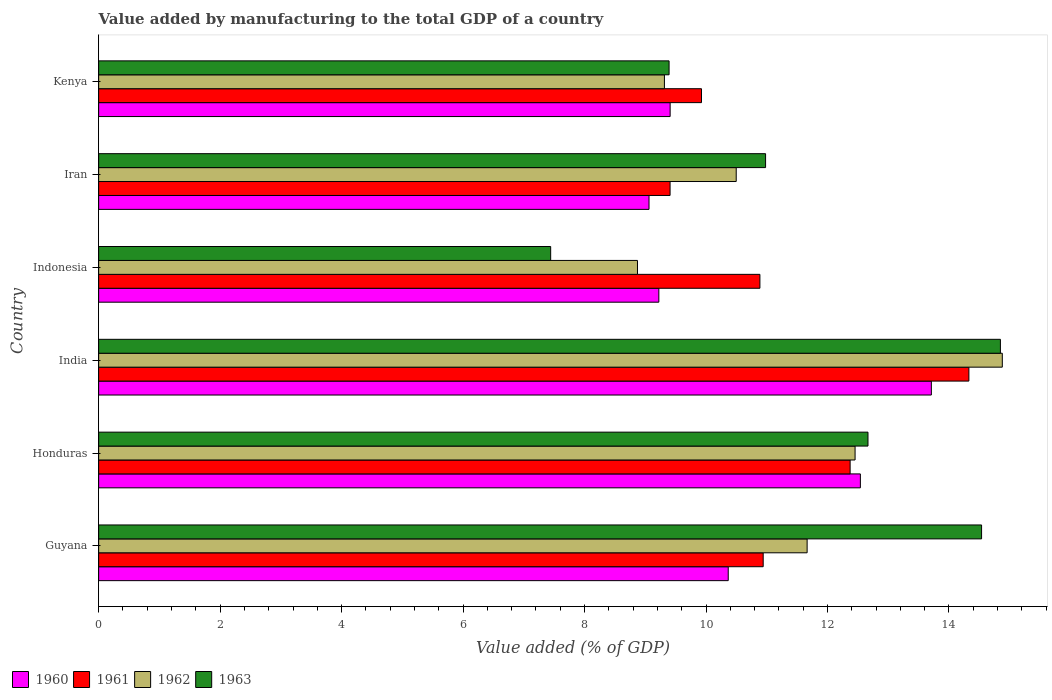What is the label of the 2nd group of bars from the top?
Give a very brief answer. Iran. In how many cases, is the number of bars for a given country not equal to the number of legend labels?
Ensure brevity in your answer.  0. What is the value added by manufacturing to the total GDP in 1960 in India?
Your answer should be very brief. 13.71. Across all countries, what is the maximum value added by manufacturing to the total GDP in 1960?
Provide a short and direct response. 13.71. Across all countries, what is the minimum value added by manufacturing to the total GDP in 1963?
Provide a short and direct response. 7.44. In which country was the value added by manufacturing to the total GDP in 1962 maximum?
Offer a very short reply. India. In which country was the value added by manufacturing to the total GDP in 1961 minimum?
Your answer should be compact. Iran. What is the total value added by manufacturing to the total GDP in 1961 in the graph?
Provide a succinct answer. 67.86. What is the difference between the value added by manufacturing to the total GDP in 1963 in Iran and that in Kenya?
Your response must be concise. 1.59. What is the difference between the value added by manufacturing to the total GDP in 1962 in Kenya and the value added by manufacturing to the total GDP in 1960 in Iran?
Ensure brevity in your answer.  0.25. What is the average value added by manufacturing to the total GDP in 1963 per country?
Give a very brief answer. 11.64. What is the difference between the value added by manufacturing to the total GDP in 1963 and value added by manufacturing to the total GDP in 1962 in Guyana?
Offer a terse response. 2.87. In how many countries, is the value added by manufacturing to the total GDP in 1962 greater than 12.8 %?
Provide a short and direct response. 1. What is the ratio of the value added by manufacturing to the total GDP in 1963 in Guyana to that in India?
Make the answer very short. 0.98. Is the value added by manufacturing to the total GDP in 1963 in Guyana less than that in India?
Your answer should be compact. Yes. What is the difference between the highest and the second highest value added by manufacturing to the total GDP in 1961?
Make the answer very short. 1.96. What is the difference between the highest and the lowest value added by manufacturing to the total GDP in 1960?
Your response must be concise. 4.65. Is the sum of the value added by manufacturing to the total GDP in 1961 in Indonesia and Iran greater than the maximum value added by manufacturing to the total GDP in 1962 across all countries?
Your response must be concise. Yes. Is it the case that in every country, the sum of the value added by manufacturing to the total GDP in 1962 and value added by manufacturing to the total GDP in 1961 is greater than the sum of value added by manufacturing to the total GDP in 1960 and value added by manufacturing to the total GDP in 1963?
Offer a very short reply. No. What does the 1st bar from the top in Honduras represents?
Offer a terse response. 1963. Is it the case that in every country, the sum of the value added by manufacturing to the total GDP in 1963 and value added by manufacturing to the total GDP in 1960 is greater than the value added by manufacturing to the total GDP in 1962?
Ensure brevity in your answer.  Yes. How many bars are there?
Offer a very short reply. 24. How many countries are there in the graph?
Give a very brief answer. 6. What is the difference between two consecutive major ticks on the X-axis?
Provide a succinct answer. 2. How many legend labels are there?
Your answer should be very brief. 4. How are the legend labels stacked?
Your answer should be compact. Horizontal. What is the title of the graph?
Offer a terse response. Value added by manufacturing to the total GDP of a country. Does "2008" appear as one of the legend labels in the graph?
Your answer should be compact. No. What is the label or title of the X-axis?
Give a very brief answer. Value added (% of GDP). What is the Value added (% of GDP) of 1960 in Guyana?
Your answer should be compact. 10.37. What is the Value added (% of GDP) of 1961 in Guyana?
Provide a succinct answer. 10.94. What is the Value added (% of GDP) of 1962 in Guyana?
Keep it short and to the point. 11.66. What is the Value added (% of GDP) in 1963 in Guyana?
Make the answer very short. 14.54. What is the Value added (% of GDP) in 1960 in Honduras?
Your answer should be compact. 12.54. What is the Value added (% of GDP) in 1961 in Honduras?
Your answer should be compact. 12.37. What is the Value added (% of GDP) in 1962 in Honduras?
Provide a short and direct response. 12.45. What is the Value added (% of GDP) in 1963 in Honduras?
Your answer should be compact. 12.67. What is the Value added (% of GDP) of 1960 in India?
Provide a short and direct response. 13.71. What is the Value added (% of GDP) in 1961 in India?
Offer a very short reply. 14.33. What is the Value added (% of GDP) in 1962 in India?
Provide a succinct answer. 14.88. What is the Value added (% of GDP) of 1963 in India?
Provide a short and direct response. 14.85. What is the Value added (% of GDP) of 1960 in Indonesia?
Offer a very short reply. 9.22. What is the Value added (% of GDP) of 1961 in Indonesia?
Keep it short and to the point. 10.89. What is the Value added (% of GDP) in 1962 in Indonesia?
Your answer should be very brief. 8.87. What is the Value added (% of GDP) of 1963 in Indonesia?
Keep it short and to the point. 7.44. What is the Value added (% of GDP) in 1960 in Iran?
Your answer should be very brief. 9.06. What is the Value added (% of GDP) of 1961 in Iran?
Your answer should be very brief. 9.41. What is the Value added (% of GDP) of 1962 in Iran?
Make the answer very short. 10.5. What is the Value added (% of GDP) of 1963 in Iran?
Offer a terse response. 10.98. What is the Value added (% of GDP) of 1960 in Kenya?
Make the answer very short. 9.41. What is the Value added (% of GDP) in 1961 in Kenya?
Offer a terse response. 9.93. What is the Value added (% of GDP) in 1962 in Kenya?
Provide a succinct answer. 9.32. What is the Value added (% of GDP) in 1963 in Kenya?
Provide a short and direct response. 9.39. Across all countries, what is the maximum Value added (% of GDP) of 1960?
Ensure brevity in your answer.  13.71. Across all countries, what is the maximum Value added (% of GDP) in 1961?
Your answer should be very brief. 14.33. Across all countries, what is the maximum Value added (% of GDP) of 1962?
Provide a short and direct response. 14.88. Across all countries, what is the maximum Value added (% of GDP) of 1963?
Provide a succinct answer. 14.85. Across all countries, what is the minimum Value added (% of GDP) in 1960?
Give a very brief answer. 9.06. Across all countries, what is the minimum Value added (% of GDP) in 1961?
Your answer should be very brief. 9.41. Across all countries, what is the minimum Value added (% of GDP) in 1962?
Make the answer very short. 8.87. Across all countries, what is the minimum Value added (% of GDP) in 1963?
Keep it short and to the point. 7.44. What is the total Value added (% of GDP) of 1960 in the graph?
Offer a very short reply. 64.31. What is the total Value added (% of GDP) in 1961 in the graph?
Ensure brevity in your answer.  67.86. What is the total Value added (% of GDP) in 1962 in the graph?
Provide a short and direct response. 67.68. What is the total Value added (% of GDP) of 1963 in the graph?
Your answer should be very brief. 69.86. What is the difference between the Value added (% of GDP) of 1960 in Guyana and that in Honduras?
Provide a short and direct response. -2.18. What is the difference between the Value added (% of GDP) in 1961 in Guyana and that in Honduras?
Your answer should be very brief. -1.43. What is the difference between the Value added (% of GDP) in 1962 in Guyana and that in Honduras?
Offer a terse response. -0.79. What is the difference between the Value added (% of GDP) of 1963 in Guyana and that in Honduras?
Provide a succinct answer. 1.87. What is the difference between the Value added (% of GDP) in 1960 in Guyana and that in India?
Keep it short and to the point. -3.34. What is the difference between the Value added (% of GDP) in 1961 in Guyana and that in India?
Offer a very short reply. -3.39. What is the difference between the Value added (% of GDP) in 1962 in Guyana and that in India?
Provide a short and direct response. -3.21. What is the difference between the Value added (% of GDP) in 1963 in Guyana and that in India?
Provide a short and direct response. -0.31. What is the difference between the Value added (% of GDP) in 1960 in Guyana and that in Indonesia?
Give a very brief answer. 1.14. What is the difference between the Value added (% of GDP) in 1961 in Guyana and that in Indonesia?
Offer a very short reply. 0.05. What is the difference between the Value added (% of GDP) in 1962 in Guyana and that in Indonesia?
Make the answer very short. 2.79. What is the difference between the Value added (% of GDP) of 1963 in Guyana and that in Indonesia?
Provide a short and direct response. 7.09. What is the difference between the Value added (% of GDP) of 1960 in Guyana and that in Iran?
Offer a terse response. 1.3. What is the difference between the Value added (% of GDP) of 1961 in Guyana and that in Iran?
Your answer should be compact. 1.53. What is the difference between the Value added (% of GDP) in 1962 in Guyana and that in Iran?
Make the answer very short. 1.17. What is the difference between the Value added (% of GDP) of 1963 in Guyana and that in Iran?
Make the answer very short. 3.56. What is the difference between the Value added (% of GDP) of 1960 in Guyana and that in Kenya?
Your answer should be compact. 0.96. What is the difference between the Value added (% of GDP) of 1961 in Guyana and that in Kenya?
Give a very brief answer. 1.02. What is the difference between the Value added (% of GDP) in 1962 in Guyana and that in Kenya?
Make the answer very short. 2.35. What is the difference between the Value added (% of GDP) of 1963 in Guyana and that in Kenya?
Make the answer very short. 5.14. What is the difference between the Value added (% of GDP) of 1960 in Honduras and that in India?
Make the answer very short. -1.17. What is the difference between the Value added (% of GDP) in 1961 in Honduras and that in India?
Your response must be concise. -1.96. What is the difference between the Value added (% of GDP) of 1962 in Honduras and that in India?
Give a very brief answer. -2.42. What is the difference between the Value added (% of GDP) of 1963 in Honduras and that in India?
Provide a short and direct response. -2.18. What is the difference between the Value added (% of GDP) of 1960 in Honduras and that in Indonesia?
Offer a very short reply. 3.32. What is the difference between the Value added (% of GDP) of 1961 in Honduras and that in Indonesia?
Make the answer very short. 1.49. What is the difference between the Value added (% of GDP) of 1962 in Honduras and that in Indonesia?
Your response must be concise. 3.58. What is the difference between the Value added (% of GDP) in 1963 in Honduras and that in Indonesia?
Make the answer very short. 5.22. What is the difference between the Value added (% of GDP) of 1960 in Honduras and that in Iran?
Make the answer very short. 3.48. What is the difference between the Value added (% of GDP) in 1961 in Honduras and that in Iran?
Keep it short and to the point. 2.96. What is the difference between the Value added (% of GDP) in 1962 in Honduras and that in Iran?
Provide a short and direct response. 1.96. What is the difference between the Value added (% of GDP) in 1963 in Honduras and that in Iran?
Give a very brief answer. 1.69. What is the difference between the Value added (% of GDP) of 1960 in Honduras and that in Kenya?
Give a very brief answer. 3.13. What is the difference between the Value added (% of GDP) of 1961 in Honduras and that in Kenya?
Make the answer very short. 2.45. What is the difference between the Value added (% of GDP) in 1962 in Honduras and that in Kenya?
Offer a terse response. 3.14. What is the difference between the Value added (% of GDP) in 1963 in Honduras and that in Kenya?
Provide a short and direct response. 3.27. What is the difference between the Value added (% of GDP) in 1960 in India and that in Indonesia?
Offer a very short reply. 4.49. What is the difference between the Value added (% of GDP) of 1961 in India and that in Indonesia?
Provide a short and direct response. 3.44. What is the difference between the Value added (% of GDP) of 1962 in India and that in Indonesia?
Provide a short and direct response. 6.01. What is the difference between the Value added (% of GDP) in 1963 in India and that in Indonesia?
Give a very brief answer. 7.4. What is the difference between the Value added (% of GDP) of 1960 in India and that in Iran?
Provide a short and direct response. 4.65. What is the difference between the Value added (% of GDP) in 1961 in India and that in Iran?
Keep it short and to the point. 4.92. What is the difference between the Value added (% of GDP) in 1962 in India and that in Iran?
Make the answer very short. 4.38. What is the difference between the Value added (% of GDP) in 1963 in India and that in Iran?
Offer a very short reply. 3.87. What is the difference between the Value added (% of GDP) in 1960 in India and that in Kenya?
Keep it short and to the point. 4.3. What is the difference between the Value added (% of GDP) in 1961 in India and that in Kenya?
Your answer should be compact. 4.4. What is the difference between the Value added (% of GDP) of 1962 in India and that in Kenya?
Provide a succinct answer. 5.56. What is the difference between the Value added (% of GDP) in 1963 in India and that in Kenya?
Your answer should be very brief. 5.45. What is the difference between the Value added (% of GDP) in 1960 in Indonesia and that in Iran?
Your answer should be compact. 0.16. What is the difference between the Value added (% of GDP) of 1961 in Indonesia and that in Iran?
Your response must be concise. 1.48. What is the difference between the Value added (% of GDP) of 1962 in Indonesia and that in Iran?
Provide a succinct answer. -1.63. What is the difference between the Value added (% of GDP) in 1963 in Indonesia and that in Iran?
Provide a short and direct response. -3.54. What is the difference between the Value added (% of GDP) in 1960 in Indonesia and that in Kenya?
Make the answer very short. -0.19. What is the difference between the Value added (% of GDP) of 1961 in Indonesia and that in Kenya?
Offer a very short reply. 0.96. What is the difference between the Value added (% of GDP) of 1962 in Indonesia and that in Kenya?
Keep it short and to the point. -0.44. What is the difference between the Value added (% of GDP) of 1963 in Indonesia and that in Kenya?
Offer a terse response. -1.95. What is the difference between the Value added (% of GDP) of 1960 in Iran and that in Kenya?
Provide a short and direct response. -0.35. What is the difference between the Value added (% of GDP) of 1961 in Iran and that in Kenya?
Ensure brevity in your answer.  -0.52. What is the difference between the Value added (% of GDP) in 1962 in Iran and that in Kenya?
Offer a very short reply. 1.18. What is the difference between the Value added (% of GDP) in 1963 in Iran and that in Kenya?
Provide a succinct answer. 1.59. What is the difference between the Value added (% of GDP) of 1960 in Guyana and the Value added (% of GDP) of 1961 in Honduras?
Offer a very short reply. -2.01. What is the difference between the Value added (% of GDP) of 1960 in Guyana and the Value added (% of GDP) of 1962 in Honduras?
Your answer should be compact. -2.09. What is the difference between the Value added (% of GDP) in 1960 in Guyana and the Value added (% of GDP) in 1963 in Honduras?
Provide a short and direct response. -2.3. What is the difference between the Value added (% of GDP) in 1961 in Guyana and the Value added (% of GDP) in 1962 in Honduras?
Make the answer very short. -1.51. What is the difference between the Value added (% of GDP) of 1961 in Guyana and the Value added (% of GDP) of 1963 in Honduras?
Give a very brief answer. -1.73. What is the difference between the Value added (% of GDP) of 1962 in Guyana and the Value added (% of GDP) of 1963 in Honduras?
Give a very brief answer. -1. What is the difference between the Value added (% of GDP) of 1960 in Guyana and the Value added (% of GDP) of 1961 in India?
Ensure brevity in your answer.  -3.96. What is the difference between the Value added (% of GDP) of 1960 in Guyana and the Value added (% of GDP) of 1962 in India?
Offer a very short reply. -4.51. What is the difference between the Value added (% of GDP) of 1960 in Guyana and the Value added (% of GDP) of 1963 in India?
Ensure brevity in your answer.  -4.48. What is the difference between the Value added (% of GDP) of 1961 in Guyana and the Value added (% of GDP) of 1962 in India?
Provide a short and direct response. -3.94. What is the difference between the Value added (% of GDP) in 1961 in Guyana and the Value added (% of GDP) in 1963 in India?
Offer a very short reply. -3.91. What is the difference between the Value added (% of GDP) in 1962 in Guyana and the Value added (% of GDP) in 1963 in India?
Give a very brief answer. -3.18. What is the difference between the Value added (% of GDP) in 1960 in Guyana and the Value added (% of GDP) in 1961 in Indonesia?
Offer a terse response. -0.52. What is the difference between the Value added (% of GDP) in 1960 in Guyana and the Value added (% of GDP) in 1962 in Indonesia?
Provide a short and direct response. 1.49. What is the difference between the Value added (% of GDP) of 1960 in Guyana and the Value added (% of GDP) of 1963 in Indonesia?
Keep it short and to the point. 2.92. What is the difference between the Value added (% of GDP) of 1961 in Guyana and the Value added (% of GDP) of 1962 in Indonesia?
Keep it short and to the point. 2.07. What is the difference between the Value added (% of GDP) of 1961 in Guyana and the Value added (% of GDP) of 1963 in Indonesia?
Offer a very short reply. 3.5. What is the difference between the Value added (% of GDP) of 1962 in Guyana and the Value added (% of GDP) of 1963 in Indonesia?
Offer a very short reply. 4.22. What is the difference between the Value added (% of GDP) in 1960 in Guyana and the Value added (% of GDP) in 1961 in Iran?
Ensure brevity in your answer.  0.96. What is the difference between the Value added (% of GDP) of 1960 in Guyana and the Value added (% of GDP) of 1962 in Iran?
Offer a very short reply. -0.13. What is the difference between the Value added (% of GDP) of 1960 in Guyana and the Value added (% of GDP) of 1963 in Iran?
Keep it short and to the point. -0.61. What is the difference between the Value added (% of GDP) of 1961 in Guyana and the Value added (% of GDP) of 1962 in Iran?
Your answer should be very brief. 0.44. What is the difference between the Value added (% of GDP) in 1961 in Guyana and the Value added (% of GDP) in 1963 in Iran?
Your response must be concise. -0.04. What is the difference between the Value added (% of GDP) in 1962 in Guyana and the Value added (% of GDP) in 1963 in Iran?
Provide a succinct answer. 0.68. What is the difference between the Value added (% of GDP) of 1960 in Guyana and the Value added (% of GDP) of 1961 in Kenya?
Provide a short and direct response. 0.44. What is the difference between the Value added (% of GDP) in 1960 in Guyana and the Value added (% of GDP) in 1962 in Kenya?
Offer a terse response. 1.05. What is the difference between the Value added (% of GDP) of 1961 in Guyana and the Value added (% of GDP) of 1962 in Kenya?
Provide a succinct answer. 1.63. What is the difference between the Value added (% of GDP) in 1961 in Guyana and the Value added (% of GDP) in 1963 in Kenya?
Your response must be concise. 1.55. What is the difference between the Value added (% of GDP) of 1962 in Guyana and the Value added (% of GDP) of 1963 in Kenya?
Your answer should be very brief. 2.27. What is the difference between the Value added (% of GDP) of 1960 in Honduras and the Value added (% of GDP) of 1961 in India?
Offer a very short reply. -1.79. What is the difference between the Value added (% of GDP) in 1960 in Honduras and the Value added (% of GDP) in 1962 in India?
Provide a succinct answer. -2.34. What is the difference between the Value added (% of GDP) in 1960 in Honduras and the Value added (% of GDP) in 1963 in India?
Ensure brevity in your answer.  -2.31. What is the difference between the Value added (% of GDP) in 1961 in Honduras and the Value added (% of GDP) in 1962 in India?
Ensure brevity in your answer.  -2.51. What is the difference between the Value added (% of GDP) of 1961 in Honduras and the Value added (% of GDP) of 1963 in India?
Make the answer very short. -2.47. What is the difference between the Value added (% of GDP) in 1962 in Honduras and the Value added (% of GDP) in 1963 in India?
Your response must be concise. -2.39. What is the difference between the Value added (% of GDP) of 1960 in Honduras and the Value added (% of GDP) of 1961 in Indonesia?
Offer a terse response. 1.65. What is the difference between the Value added (% of GDP) in 1960 in Honduras and the Value added (% of GDP) in 1962 in Indonesia?
Make the answer very short. 3.67. What is the difference between the Value added (% of GDP) of 1960 in Honduras and the Value added (% of GDP) of 1963 in Indonesia?
Provide a short and direct response. 5.1. What is the difference between the Value added (% of GDP) in 1961 in Honduras and the Value added (% of GDP) in 1962 in Indonesia?
Ensure brevity in your answer.  3.5. What is the difference between the Value added (% of GDP) of 1961 in Honduras and the Value added (% of GDP) of 1963 in Indonesia?
Provide a short and direct response. 4.93. What is the difference between the Value added (% of GDP) of 1962 in Honduras and the Value added (% of GDP) of 1963 in Indonesia?
Provide a short and direct response. 5.01. What is the difference between the Value added (% of GDP) in 1960 in Honduras and the Value added (% of GDP) in 1961 in Iran?
Make the answer very short. 3.13. What is the difference between the Value added (% of GDP) in 1960 in Honduras and the Value added (% of GDP) in 1962 in Iran?
Your answer should be compact. 2.04. What is the difference between the Value added (% of GDP) of 1960 in Honduras and the Value added (% of GDP) of 1963 in Iran?
Offer a terse response. 1.56. What is the difference between the Value added (% of GDP) in 1961 in Honduras and the Value added (% of GDP) in 1962 in Iran?
Make the answer very short. 1.88. What is the difference between the Value added (% of GDP) in 1961 in Honduras and the Value added (% of GDP) in 1963 in Iran?
Give a very brief answer. 1.39. What is the difference between the Value added (% of GDP) of 1962 in Honduras and the Value added (% of GDP) of 1963 in Iran?
Your answer should be compact. 1.47. What is the difference between the Value added (% of GDP) in 1960 in Honduras and the Value added (% of GDP) in 1961 in Kenya?
Keep it short and to the point. 2.62. What is the difference between the Value added (% of GDP) of 1960 in Honduras and the Value added (% of GDP) of 1962 in Kenya?
Offer a very short reply. 3.23. What is the difference between the Value added (% of GDP) in 1960 in Honduras and the Value added (% of GDP) in 1963 in Kenya?
Your answer should be very brief. 3.15. What is the difference between the Value added (% of GDP) of 1961 in Honduras and the Value added (% of GDP) of 1962 in Kenya?
Offer a very short reply. 3.06. What is the difference between the Value added (% of GDP) in 1961 in Honduras and the Value added (% of GDP) in 1963 in Kenya?
Keep it short and to the point. 2.98. What is the difference between the Value added (% of GDP) of 1962 in Honduras and the Value added (% of GDP) of 1963 in Kenya?
Offer a terse response. 3.06. What is the difference between the Value added (% of GDP) of 1960 in India and the Value added (% of GDP) of 1961 in Indonesia?
Give a very brief answer. 2.82. What is the difference between the Value added (% of GDP) of 1960 in India and the Value added (% of GDP) of 1962 in Indonesia?
Ensure brevity in your answer.  4.84. What is the difference between the Value added (% of GDP) of 1960 in India and the Value added (% of GDP) of 1963 in Indonesia?
Make the answer very short. 6.27. What is the difference between the Value added (% of GDP) of 1961 in India and the Value added (% of GDP) of 1962 in Indonesia?
Your response must be concise. 5.46. What is the difference between the Value added (% of GDP) of 1961 in India and the Value added (% of GDP) of 1963 in Indonesia?
Ensure brevity in your answer.  6.89. What is the difference between the Value added (% of GDP) of 1962 in India and the Value added (% of GDP) of 1963 in Indonesia?
Offer a terse response. 7.44. What is the difference between the Value added (% of GDP) in 1960 in India and the Value added (% of GDP) in 1961 in Iran?
Give a very brief answer. 4.3. What is the difference between the Value added (% of GDP) in 1960 in India and the Value added (% of GDP) in 1962 in Iran?
Provide a short and direct response. 3.21. What is the difference between the Value added (% of GDP) in 1960 in India and the Value added (% of GDP) in 1963 in Iran?
Your answer should be compact. 2.73. What is the difference between the Value added (% of GDP) in 1961 in India and the Value added (% of GDP) in 1962 in Iran?
Keep it short and to the point. 3.83. What is the difference between the Value added (% of GDP) in 1961 in India and the Value added (% of GDP) in 1963 in Iran?
Make the answer very short. 3.35. What is the difference between the Value added (% of GDP) in 1962 in India and the Value added (% of GDP) in 1963 in Iran?
Keep it short and to the point. 3.9. What is the difference between the Value added (% of GDP) of 1960 in India and the Value added (% of GDP) of 1961 in Kenya?
Your answer should be very brief. 3.78. What is the difference between the Value added (% of GDP) in 1960 in India and the Value added (% of GDP) in 1962 in Kenya?
Offer a terse response. 4.39. What is the difference between the Value added (% of GDP) in 1960 in India and the Value added (% of GDP) in 1963 in Kenya?
Your response must be concise. 4.32. What is the difference between the Value added (% of GDP) in 1961 in India and the Value added (% of GDP) in 1962 in Kenya?
Offer a very short reply. 5.01. What is the difference between the Value added (% of GDP) of 1961 in India and the Value added (% of GDP) of 1963 in Kenya?
Your answer should be very brief. 4.94. What is the difference between the Value added (% of GDP) in 1962 in India and the Value added (% of GDP) in 1963 in Kenya?
Provide a short and direct response. 5.49. What is the difference between the Value added (% of GDP) in 1960 in Indonesia and the Value added (% of GDP) in 1961 in Iran?
Keep it short and to the point. -0.18. What is the difference between the Value added (% of GDP) of 1960 in Indonesia and the Value added (% of GDP) of 1962 in Iran?
Offer a very short reply. -1.27. What is the difference between the Value added (% of GDP) of 1960 in Indonesia and the Value added (% of GDP) of 1963 in Iran?
Offer a terse response. -1.76. What is the difference between the Value added (% of GDP) in 1961 in Indonesia and the Value added (% of GDP) in 1962 in Iran?
Make the answer very short. 0.39. What is the difference between the Value added (% of GDP) of 1961 in Indonesia and the Value added (% of GDP) of 1963 in Iran?
Your response must be concise. -0.09. What is the difference between the Value added (% of GDP) in 1962 in Indonesia and the Value added (% of GDP) in 1963 in Iran?
Your response must be concise. -2.11. What is the difference between the Value added (% of GDP) in 1960 in Indonesia and the Value added (% of GDP) in 1961 in Kenya?
Your answer should be compact. -0.7. What is the difference between the Value added (% of GDP) in 1960 in Indonesia and the Value added (% of GDP) in 1962 in Kenya?
Provide a short and direct response. -0.09. What is the difference between the Value added (% of GDP) of 1960 in Indonesia and the Value added (% of GDP) of 1963 in Kenya?
Provide a succinct answer. -0.17. What is the difference between the Value added (% of GDP) of 1961 in Indonesia and the Value added (% of GDP) of 1962 in Kenya?
Keep it short and to the point. 1.57. What is the difference between the Value added (% of GDP) in 1961 in Indonesia and the Value added (% of GDP) in 1963 in Kenya?
Ensure brevity in your answer.  1.5. What is the difference between the Value added (% of GDP) of 1962 in Indonesia and the Value added (% of GDP) of 1963 in Kenya?
Offer a very short reply. -0.52. What is the difference between the Value added (% of GDP) in 1960 in Iran and the Value added (% of GDP) in 1961 in Kenya?
Ensure brevity in your answer.  -0.86. What is the difference between the Value added (% of GDP) of 1960 in Iran and the Value added (% of GDP) of 1962 in Kenya?
Ensure brevity in your answer.  -0.25. What is the difference between the Value added (% of GDP) of 1960 in Iran and the Value added (% of GDP) of 1963 in Kenya?
Ensure brevity in your answer.  -0.33. What is the difference between the Value added (% of GDP) of 1961 in Iran and the Value added (% of GDP) of 1962 in Kenya?
Your answer should be very brief. 0.09. What is the difference between the Value added (% of GDP) of 1961 in Iran and the Value added (% of GDP) of 1963 in Kenya?
Provide a succinct answer. 0.02. What is the difference between the Value added (% of GDP) in 1962 in Iran and the Value added (% of GDP) in 1963 in Kenya?
Ensure brevity in your answer.  1.11. What is the average Value added (% of GDP) in 1960 per country?
Provide a succinct answer. 10.72. What is the average Value added (% of GDP) of 1961 per country?
Your answer should be very brief. 11.31. What is the average Value added (% of GDP) of 1962 per country?
Keep it short and to the point. 11.28. What is the average Value added (% of GDP) of 1963 per country?
Ensure brevity in your answer.  11.64. What is the difference between the Value added (% of GDP) of 1960 and Value added (% of GDP) of 1961 in Guyana?
Make the answer very short. -0.58. What is the difference between the Value added (% of GDP) of 1960 and Value added (% of GDP) of 1962 in Guyana?
Give a very brief answer. -1.3. What is the difference between the Value added (% of GDP) of 1960 and Value added (% of GDP) of 1963 in Guyana?
Your answer should be very brief. -4.17. What is the difference between the Value added (% of GDP) of 1961 and Value added (% of GDP) of 1962 in Guyana?
Offer a very short reply. -0.72. What is the difference between the Value added (% of GDP) in 1961 and Value added (% of GDP) in 1963 in Guyana?
Offer a very short reply. -3.6. What is the difference between the Value added (% of GDP) in 1962 and Value added (% of GDP) in 1963 in Guyana?
Your response must be concise. -2.87. What is the difference between the Value added (% of GDP) of 1960 and Value added (% of GDP) of 1961 in Honduras?
Ensure brevity in your answer.  0.17. What is the difference between the Value added (% of GDP) in 1960 and Value added (% of GDP) in 1962 in Honduras?
Your response must be concise. 0.09. What is the difference between the Value added (% of GDP) in 1960 and Value added (% of GDP) in 1963 in Honduras?
Your response must be concise. -0.13. What is the difference between the Value added (% of GDP) in 1961 and Value added (% of GDP) in 1962 in Honduras?
Give a very brief answer. -0.08. What is the difference between the Value added (% of GDP) in 1961 and Value added (% of GDP) in 1963 in Honduras?
Your answer should be very brief. -0.29. What is the difference between the Value added (% of GDP) of 1962 and Value added (% of GDP) of 1963 in Honduras?
Make the answer very short. -0.21. What is the difference between the Value added (% of GDP) of 1960 and Value added (% of GDP) of 1961 in India?
Your answer should be compact. -0.62. What is the difference between the Value added (% of GDP) in 1960 and Value added (% of GDP) in 1962 in India?
Ensure brevity in your answer.  -1.17. What is the difference between the Value added (% of GDP) in 1960 and Value added (% of GDP) in 1963 in India?
Your answer should be very brief. -1.14. What is the difference between the Value added (% of GDP) in 1961 and Value added (% of GDP) in 1962 in India?
Make the answer very short. -0.55. What is the difference between the Value added (% of GDP) in 1961 and Value added (% of GDP) in 1963 in India?
Your response must be concise. -0.52. What is the difference between the Value added (% of GDP) of 1962 and Value added (% of GDP) of 1963 in India?
Give a very brief answer. 0.03. What is the difference between the Value added (% of GDP) of 1960 and Value added (% of GDP) of 1961 in Indonesia?
Your answer should be very brief. -1.66. What is the difference between the Value added (% of GDP) in 1960 and Value added (% of GDP) in 1962 in Indonesia?
Provide a succinct answer. 0.35. What is the difference between the Value added (% of GDP) of 1960 and Value added (% of GDP) of 1963 in Indonesia?
Make the answer very short. 1.78. What is the difference between the Value added (% of GDP) of 1961 and Value added (% of GDP) of 1962 in Indonesia?
Give a very brief answer. 2.02. What is the difference between the Value added (% of GDP) in 1961 and Value added (% of GDP) in 1963 in Indonesia?
Your answer should be very brief. 3.44. What is the difference between the Value added (% of GDP) of 1962 and Value added (% of GDP) of 1963 in Indonesia?
Your answer should be compact. 1.43. What is the difference between the Value added (% of GDP) in 1960 and Value added (% of GDP) in 1961 in Iran?
Offer a terse response. -0.35. What is the difference between the Value added (% of GDP) of 1960 and Value added (% of GDP) of 1962 in Iran?
Your answer should be very brief. -1.44. What is the difference between the Value added (% of GDP) of 1960 and Value added (% of GDP) of 1963 in Iran?
Keep it short and to the point. -1.92. What is the difference between the Value added (% of GDP) in 1961 and Value added (% of GDP) in 1962 in Iran?
Your answer should be compact. -1.09. What is the difference between the Value added (% of GDP) of 1961 and Value added (% of GDP) of 1963 in Iran?
Provide a short and direct response. -1.57. What is the difference between the Value added (% of GDP) of 1962 and Value added (% of GDP) of 1963 in Iran?
Offer a very short reply. -0.48. What is the difference between the Value added (% of GDP) of 1960 and Value added (% of GDP) of 1961 in Kenya?
Provide a short and direct response. -0.52. What is the difference between the Value added (% of GDP) of 1960 and Value added (% of GDP) of 1962 in Kenya?
Keep it short and to the point. 0.09. What is the difference between the Value added (% of GDP) in 1960 and Value added (% of GDP) in 1963 in Kenya?
Provide a succinct answer. 0.02. What is the difference between the Value added (% of GDP) of 1961 and Value added (% of GDP) of 1962 in Kenya?
Your answer should be very brief. 0.61. What is the difference between the Value added (% of GDP) in 1961 and Value added (% of GDP) in 1963 in Kenya?
Your response must be concise. 0.53. What is the difference between the Value added (% of GDP) of 1962 and Value added (% of GDP) of 1963 in Kenya?
Make the answer very short. -0.08. What is the ratio of the Value added (% of GDP) in 1960 in Guyana to that in Honduras?
Make the answer very short. 0.83. What is the ratio of the Value added (% of GDP) in 1961 in Guyana to that in Honduras?
Your response must be concise. 0.88. What is the ratio of the Value added (% of GDP) of 1962 in Guyana to that in Honduras?
Offer a terse response. 0.94. What is the ratio of the Value added (% of GDP) of 1963 in Guyana to that in Honduras?
Your response must be concise. 1.15. What is the ratio of the Value added (% of GDP) in 1960 in Guyana to that in India?
Your answer should be very brief. 0.76. What is the ratio of the Value added (% of GDP) of 1961 in Guyana to that in India?
Ensure brevity in your answer.  0.76. What is the ratio of the Value added (% of GDP) in 1962 in Guyana to that in India?
Provide a short and direct response. 0.78. What is the ratio of the Value added (% of GDP) of 1963 in Guyana to that in India?
Give a very brief answer. 0.98. What is the ratio of the Value added (% of GDP) of 1960 in Guyana to that in Indonesia?
Provide a short and direct response. 1.12. What is the ratio of the Value added (% of GDP) of 1962 in Guyana to that in Indonesia?
Ensure brevity in your answer.  1.31. What is the ratio of the Value added (% of GDP) in 1963 in Guyana to that in Indonesia?
Give a very brief answer. 1.95. What is the ratio of the Value added (% of GDP) of 1960 in Guyana to that in Iran?
Your answer should be compact. 1.14. What is the ratio of the Value added (% of GDP) in 1961 in Guyana to that in Iran?
Offer a terse response. 1.16. What is the ratio of the Value added (% of GDP) of 1962 in Guyana to that in Iran?
Offer a very short reply. 1.11. What is the ratio of the Value added (% of GDP) of 1963 in Guyana to that in Iran?
Your answer should be very brief. 1.32. What is the ratio of the Value added (% of GDP) in 1960 in Guyana to that in Kenya?
Keep it short and to the point. 1.1. What is the ratio of the Value added (% of GDP) in 1961 in Guyana to that in Kenya?
Your response must be concise. 1.1. What is the ratio of the Value added (% of GDP) of 1962 in Guyana to that in Kenya?
Provide a short and direct response. 1.25. What is the ratio of the Value added (% of GDP) of 1963 in Guyana to that in Kenya?
Offer a terse response. 1.55. What is the ratio of the Value added (% of GDP) in 1960 in Honduras to that in India?
Your answer should be compact. 0.91. What is the ratio of the Value added (% of GDP) in 1961 in Honduras to that in India?
Provide a succinct answer. 0.86. What is the ratio of the Value added (% of GDP) of 1962 in Honduras to that in India?
Offer a very short reply. 0.84. What is the ratio of the Value added (% of GDP) of 1963 in Honduras to that in India?
Your response must be concise. 0.85. What is the ratio of the Value added (% of GDP) in 1960 in Honduras to that in Indonesia?
Ensure brevity in your answer.  1.36. What is the ratio of the Value added (% of GDP) in 1961 in Honduras to that in Indonesia?
Offer a terse response. 1.14. What is the ratio of the Value added (% of GDP) in 1962 in Honduras to that in Indonesia?
Your response must be concise. 1.4. What is the ratio of the Value added (% of GDP) of 1963 in Honduras to that in Indonesia?
Give a very brief answer. 1.7. What is the ratio of the Value added (% of GDP) of 1960 in Honduras to that in Iran?
Keep it short and to the point. 1.38. What is the ratio of the Value added (% of GDP) in 1961 in Honduras to that in Iran?
Keep it short and to the point. 1.32. What is the ratio of the Value added (% of GDP) of 1962 in Honduras to that in Iran?
Provide a succinct answer. 1.19. What is the ratio of the Value added (% of GDP) of 1963 in Honduras to that in Iran?
Provide a short and direct response. 1.15. What is the ratio of the Value added (% of GDP) of 1960 in Honduras to that in Kenya?
Your answer should be compact. 1.33. What is the ratio of the Value added (% of GDP) of 1961 in Honduras to that in Kenya?
Your answer should be compact. 1.25. What is the ratio of the Value added (% of GDP) in 1962 in Honduras to that in Kenya?
Make the answer very short. 1.34. What is the ratio of the Value added (% of GDP) in 1963 in Honduras to that in Kenya?
Make the answer very short. 1.35. What is the ratio of the Value added (% of GDP) of 1960 in India to that in Indonesia?
Provide a succinct answer. 1.49. What is the ratio of the Value added (% of GDP) in 1961 in India to that in Indonesia?
Your answer should be very brief. 1.32. What is the ratio of the Value added (% of GDP) of 1962 in India to that in Indonesia?
Offer a terse response. 1.68. What is the ratio of the Value added (% of GDP) in 1963 in India to that in Indonesia?
Give a very brief answer. 1.99. What is the ratio of the Value added (% of GDP) of 1960 in India to that in Iran?
Provide a short and direct response. 1.51. What is the ratio of the Value added (% of GDP) in 1961 in India to that in Iran?
Offer a very short reply. 1.52. What is the ratio of the Value added (% of GDP) of 1962 in India to that in Iran?
Your answer should be compact. 1.42. What is the ratio of the Value added (% of GDP) of 1963 in India to that in Iran?
Provide a short and direct response. 1.35. What is the ratio of the Value added (% of GDP) of 1960 in India to that in Kenya?
Make the answer very short. 1.46. What is the ratio of the Value added (% of GDP) of 1961 in India to that in Kenya?
Provide a succinct answer. 1.44. What is the ratio of the Value added (% of GDP) of 1962 in India to that in Kenya?
Ensure brevity in your answer.  1.6. What is the ratio of the Value added (% of GDP) of 1963 in India to that in Kenya?
Provide a succinct answer. 1.58. What is the ratio of the Value added (% of GDP) in 1960 in Indonesia to that in Iran?
Provide a succinct answer. 1.02. What is the ratio of the Value added (% of GDP) in 1961 in Indonesia to that in Iran?
Ensure brevity in your answer.  1.16. What is the ratio of the Value added (% of GDP) in 1962 in Indonesia to that in Iran?
Provide a succinct answer. 0.85. What is the ratio of the Value added (% of GDP) in 1963 in Indonesia to that in Iran?
Your answer should be very brief. 0.68. What is the ratio of the Value added (% of GDP) of 1960 in Indonesia to that in Kenya?
Make the answer very short. 0.98. What is the ratio of the Value added (% of GDP) in 1961 in Indonesia to that in Kenya?
Provide a short and direct response. 1.1. What is the ratio of the Value added (% of GDP) of 1962 in Indonesia to that in Kenya?
Your answer should be very brief. 0.95. What is the ratio of the Value added (% of GDP) of 1963 in Indonesia to that in Kenya?
Offer a very short reply. 0.79. What is the ratio of the Value added (% of GDP) in 1960 in Iran to that in Kenya?
Ensure brevity in your answer.  0.96. What is the ratio of the Value added (% of GDP) of 1961 in Iran to that in Kenya?
Keep it short and to the point. 0.95. What is the ratio of the Value added (% of GDP) in 1962 in Iran to that in Kenya?
Keep it short and to the point. 1.13. What is the ratio of the Value added (% of GDP) in 1963 in Iran to that in Kenya?
Keep it short and to the point. 1.17. What is the difference between the highest and the second highest Value added (% of GDP) in 1960?
Keep it short and to the point. 1.17. What is the difference between the highest and the second highest Value added (% of GDP) of 1961?
Provide a short and direct response. 1.96. What is the difference between the highest and the second highest Value added (% of GDP) of 1962?
Offer a terse response. 2.42. What is the difference between the highest and the second highest Value added (% of GDP) in 1963?
Your answer should be compact. 0.31. What is the difference between the highest and the lowest Value added (% of GDP) of 1960?
Make the answer very short. 4.65. What is the difference between the highest and the lowest Value added (% of GDP) of 1961?
Ensure brevity in your answer.  4.92. What is the difference between the highest and the lowest Value added (% of GDP) of 1962?
Your answer should be very brief. 6.01. What is the difference between the highest and the lowest Value added (% of GDP) in 1963?
Make the answer very short. 7.4. 